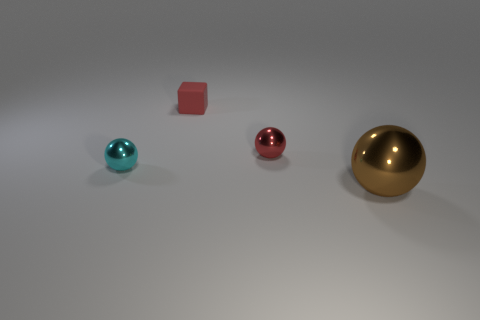What number of gray rubber things are there?
Ensure brevity in your answer.  0. What is the color of the metallic thing to the left of the metallic thing behind the small cyan metal sphere on the left side of the small red matte cube?
Provide a succinct answer. Cyan. How many things are to the right of the small cyan metal object and behind the big brown metallic object?
Give a very brief answer. 2. How many rubber things are either big red spheres or blocks?
Ensure brevity in your answer.  1. What material is the block on the right side of the tiny cyan object in front of the red rubber cube made of?
Keep it short and to the point. Rubber. What shape is the metallic object that is the same color as the tiny rubber block?
Offer a very short reply. Sphere. What shape is the red metal object that is the same size as the red matte object?
Your answer should be compact. Sphere. Are there fewer small metal spheres than brown metal objects?
Offer a terse response. No. There is a object in front of the cyan metallic object; is there a tiny cyan shiny sphere that is to the left of it?
Your response must be concise. Yes. The big brown thing that is the same material as the tiny cyan ball is what shape?
Ensure brevity in your answer.  Sphere. 